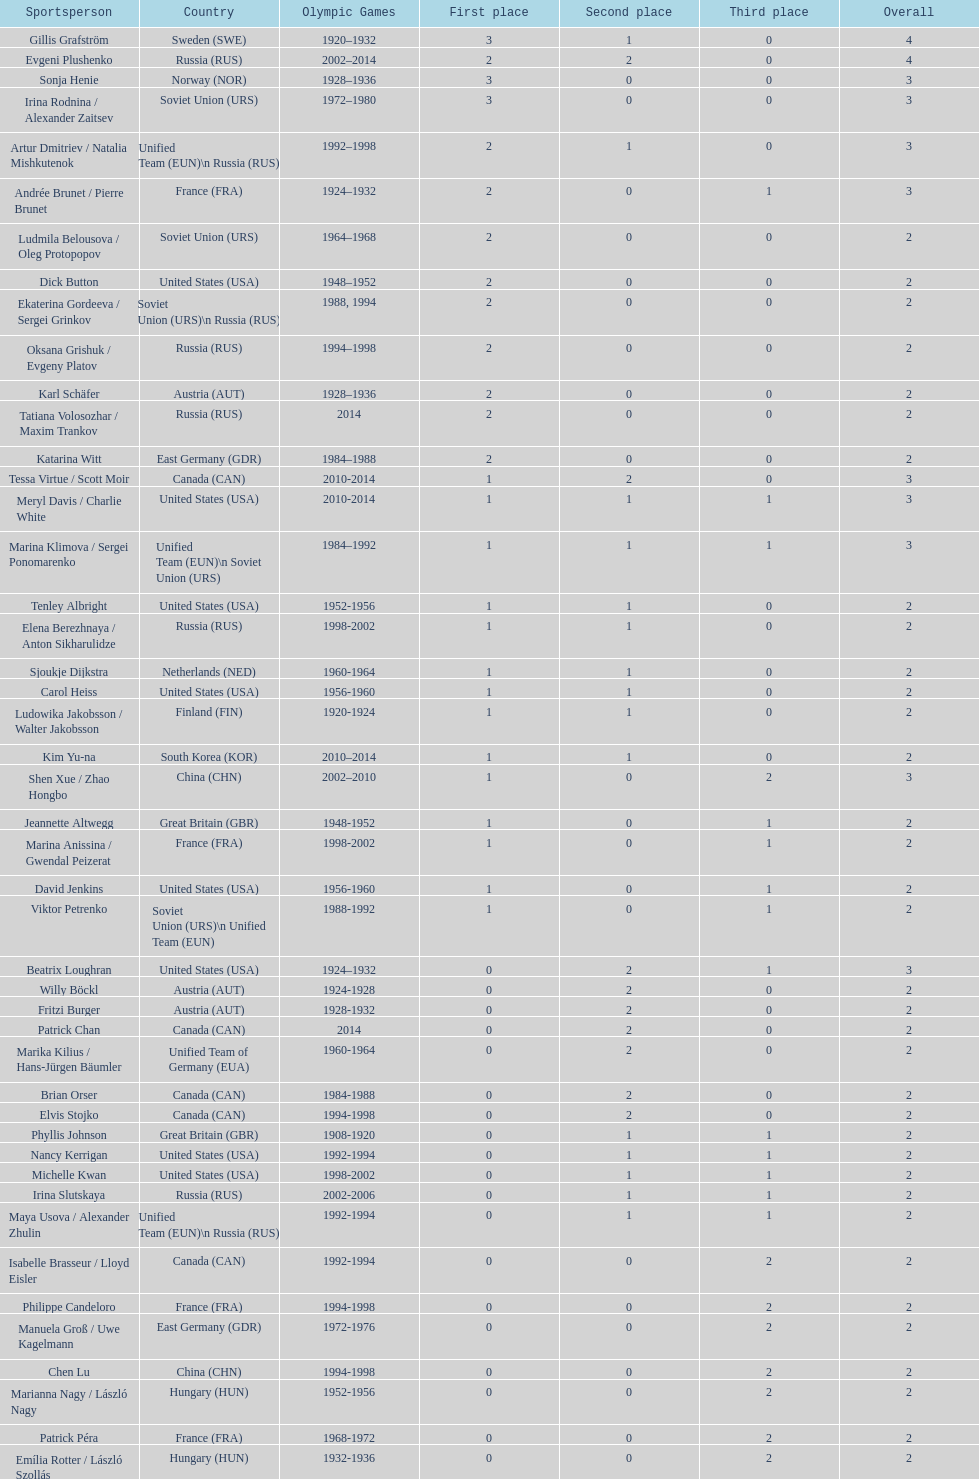Can you give me this table as a dict? {'header': ['Sportsperson', 'Country', 'Olympic Games', 'First place', 'Second place', 'Third place', 'Overall'], 'rows': [['Gillis Grafström', 'Sweden\xa0(SWE)', '1920–1932', '3', '1', '0', '4'], ['Evgeni Plushenko', 'Russia\xa0(RUS)', '2002–2014', '2', '2', '0', '4'], ['Sonja Henie', 'Norway\xa0(NOR)', '1928–1936', '3', '0', '0', '3'], ['Irina Rodnina / Alexander Zaitsev', 'Soviet Union\xa0(URS)', '1972–1980', '3', '0', '0', '3'], ['Artur Dmitriev / Natalia Mishkutenok', 'Unified Team\xa0(EUN)\\n\xa0Russia\xa0(RUS)', '1992–1998', '2', '1', '0', '3'], ['Andrée Brunet / Pierre Brunet', 'France\xa0(FRA)', '1924–1932', '2', '0', '1', '3'], ['Ludmila Belousova / Oleg Protopopov', 'Soviet Union\xa0(URS)', '1964–1968', '2', '0', '0', '2'], ['Dick Button', 'United States\xa0(USA)', '1948–1952', '2', '0', '0', '2'], ['Ekaterina Gordeeva / Sergei Grinkov', 'Soviet Union\xa0(URS)\\n\xa0Russia\xa0(RUS)', '1988, 1994', '2', '0', '0', '2'], ['Oksana Grishuk / Evgeny Platov', 'Russia\xa0(RUS)', '1994–1998', '2', '0', '0', '2'], ['Karl Schäfer', 'Austria\xa0(AUT)', '1928–1936', '2', '0', '0', '2'], ['Tatiana Volosozhar / Maxim Trankov', 'Russia\xa0(RUS)', '2014', '2', '0', '0', '2'], ['Katarina Witt', 'East Germany\xa0(GDR)', '1984–1988', '2', '0', '0', '2'], ['Tessa Virtue / Scott Moir', 'Canada\xa0(CAN)', '2010-2014', '1', '2', '0', '3'], ['Meryl Davis / Charlie White', 'United States\xa0(USA)', '2010-2014', '1', '1', '1', '3'], ['Marina Klimova / Sergei Ponomarenko', 'Unified Team\xa0(EUN)\\n\xa0Soviet Union\xa0(URS)', '1984–1992', '1', '1', '1', '3'], ['Tenley Albright', 'United States\xa0(USA)', '1952-1956', '1', '1', '0', '2'], ['Elena Berezhnaya / Anton Sikharulidze', 'Russia\xa0(RUS)', '1998-2002', '1', '1', '0', '2'], ['Sjoukje Dijkstra', 'Netherlands\xa0(NED)', '1960-1964', '1', '1', '0', '2'], ['Carol Heiss', 'United States\xa0(USA)', '1956-1960', '1', '1', '0', '2'], ['Ludowika Jakobsson / Walter Jakobsson', 'Finland\xa0(FIN)', '1920-1924', '1', '1', '0', '2'], ['Kim Yu-na', 'South Korea\xa0(KOR)', '2010–2014', '1', '1', '0', '2'], ['Shen Xue / Zhao Hongbo', 'China\xa0(CHN)', '2002–2010', '1', '0', '2', '3'], ['Jeannette Altwegg', 'Great Britain\xa0(GBR)', '1948-1952', '1', '0', '1', '2'], ['Marina Anissina / Gwendal Peizerat', 'France\xa0(FRA)', '1998-2002', '1', '0', '1', '2'], ['David Jenkins', 'United States\xa0(USA)', '1956-1960', '1', '0', '1', '2'], ['Viktor Petrenko', 'Soviet Union\xa0(URS)\\n\xa0Unified Team\xa0(EUN)', '1988-1992', '1', '0', '1', '2'], ['Beatrix Loughran', 'United States\xa0(USA)', '1924–1932', '0', '2', '1', '3'], ['Willy Böckl', 'Austria\xa0(AUT)', '1924-1928', '0', '2', '0', '2'], ['Fritzi Burger', 'Austria\xa0(AUT)', '1928-1932', '0', '2', '0', '2'], ['Patrick Chan', 'Canada\xa0(CAN)', '2014', '0', '2', '0', '2'], ['Marika Kilius / Hans-Jürgen Bäumler', 'Unified Team of Germany\xa0(EUA)', '1960-1964', '0', '2', '0', '2'], ['Brian Orser', 'Canada\xa0(CAN)', '1984-1988', '0', '2', '0', '2'], ['Elvis Stojko', 'Canada\xa0(CAN)', '1994-1998', '0', '2', '0', '2'], ['Phyllis Johnson', 'Great Britain\xa0(GBR)', '1908-1920', '0', '1', '1', '2'], ['Nancy Kerrigan', 'United States\xa0(USA)', '1992-1994', '0', '1', '1', '2'], ['Michelle Kwan', 'United States\xa0(USA)', '1998-2002', '0', '1', '1', '2'], ['Irina Slutskaya', 'Russia\xa0(RUS)', '2002-2006', '0', '1', '1', '2'], ['Maya Usova / Alexander Zhulin', 'Unified Team\xa0(EUN)\\n\xa0Russia\xa0(RUS)', '1992-1994', '0', '1', '1', '2'], ['Isabelle Brasseur / Lloyd Eisler', 'Canada\xa0(CAN)', '1992-1994', '0', '0', '2', '2'], ['Philippe Candeloro', 'France\xa0(FRA)', '1994-1998', '0', '0', '2', '2'], ['Manuela Groß / Uwe Kagelmann', 'East Germany\xa0(GDR)', '1972-1976', '0', '0', '2', '2'], ['Chen Lu', 'China\xa0(CHN)', '1994-1998', '0', '0', '2', '2'], ['Marianna Nagy / László Nagy', 'Hungary\xa0(HUN)', '1952-1956', '0', '0', '2', '2'], ['Patrick Péra', 'France\xa0(FRA)', '1968-1972', '0', '0', '2', '2'], ['Emília Rotter / László Szollás', 'Hungary\xa0(HUN)', '1932-1936', '0', '0', '2', '2'], ['Aliona Savchenko / Robin Szolkowy', 'Germany\xa0(GER)', '2010-2014', '0', '0', '2', '2']]} How many more silver medals did gillis grafström have compared to sonja henie? 1. 